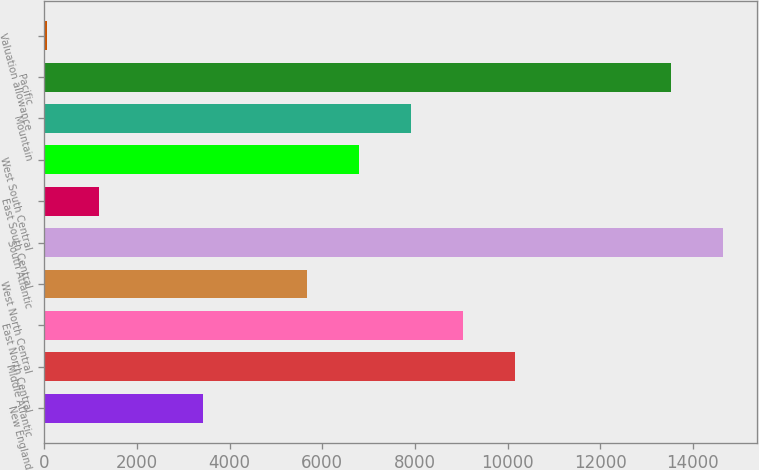<chart> <loc_0><loc_0><loc_500><loc_500><bar_chart><fcel>New England<fcel>Middle Atlantic<fcel>East North Central<fcel>West North Central<fcel>South Atlantic<fcel>East South Central<fcel>West South Central<fcel>Mountain<fcel>Pacific<fcel>Valuation allowance<nl><fcel>3423.69<fcel>10157.1<fcel>9034.84<fcel>5668.15<fcel>14646<fcel>1179.23<fcel>6790.38<fcel>7912.61<fcel>13523.8<fcel>57<nl></chart> 